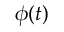<formula> <loc_0><loc_0><loc_500><loc_500>\phi ( t )</formula> 